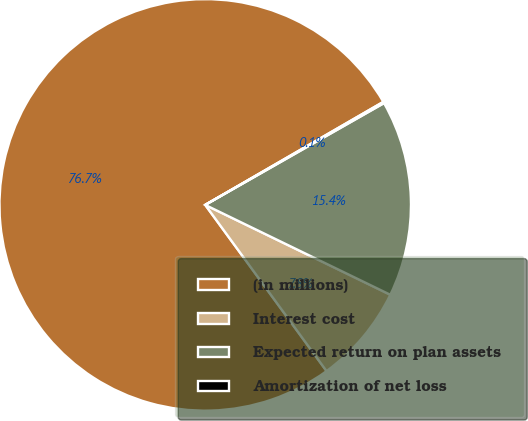Convert chart to OTSL. <chart><loc_0><loc_0><loc_500><loc_500><pie_chart><fcel>(in millions)<fcel>Interest cost<fcel>Expected return on plan assets<fcel>Amortization of net loss<nl><fcel>76.69%<fcel>7.77%<fcel>15.43%<fcel>0.11%<nl></chart> 